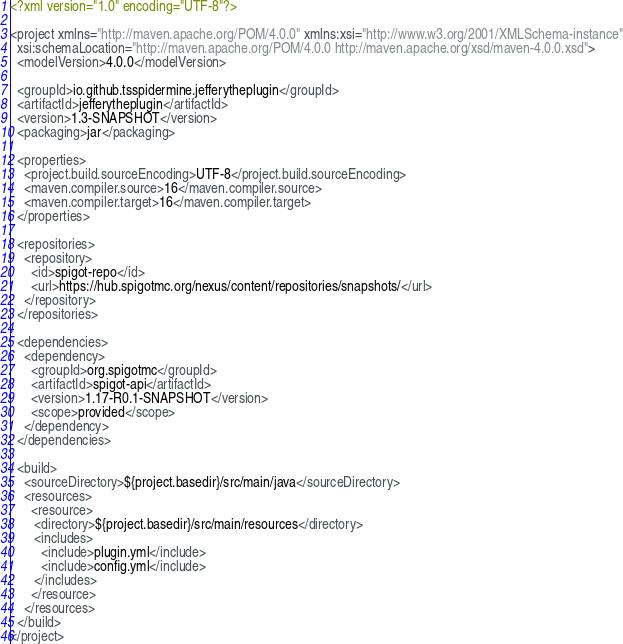<code> <loc_0><loc_0><loc_500><loc_500><_XML_><?xml version="1.0" encoding="UTF-8"?>

<project xmlns="http://maven.apache.org/POM/4.0.0" xmlns:xsi="http://www.w3.org/2001/XMLSchema-instance"
  xsi:schemaLocation="http://maven.apache.org/POM/4.0.0 http://maven.apache.org/xsd/maven-4.0.0.xsd">
  <modelVersion>4.0.0</modelVersion>

  <groupId>io.github.tsspidermine.jefferytheplugin</groupId>
  <artifactId>jefferytheplugin</artifactId>
  <version>1.3-SNAPSHOT</version>
  <packaging>jar</packaging>

  <properties>
    <project.build.sourceEncoding>UTF-8</project.build.sourceEncoding>
    <maven.compiler.source>16</maven.compiler.source>
    <maven.compiler.target>16</maven.compiler.target>
  </properties>

  <repositories>
    <repository>
      <id>spigot-repo</id>
      <url>https://hub.spigotmc.org/nexus/content/repositories/snapshots/</url>
    </repository>
  </repositories>

  <dependencies>
    <dependency>
      <groupId>org.spigotmc</groupId>
      <artifactId>spigot-api</artifactId>
      <version>1.17-R0.1-SNAPSHOT</version>
      <scope>provided</scope>
    </dependency>
  </dependencies>

  <build>
    <sourceDirectory>${project.basedir}/src/main/java</sourceDirectory>
    <resources>
      <resource>
       <directory>${project.basedir}/src/main/resources</directory>
       <includes>
         <include>plugin.yml</include>
         <include>config.yml</include>
       </includes>
      </resource>
    </resources>
  </build>
</project>
</code> 